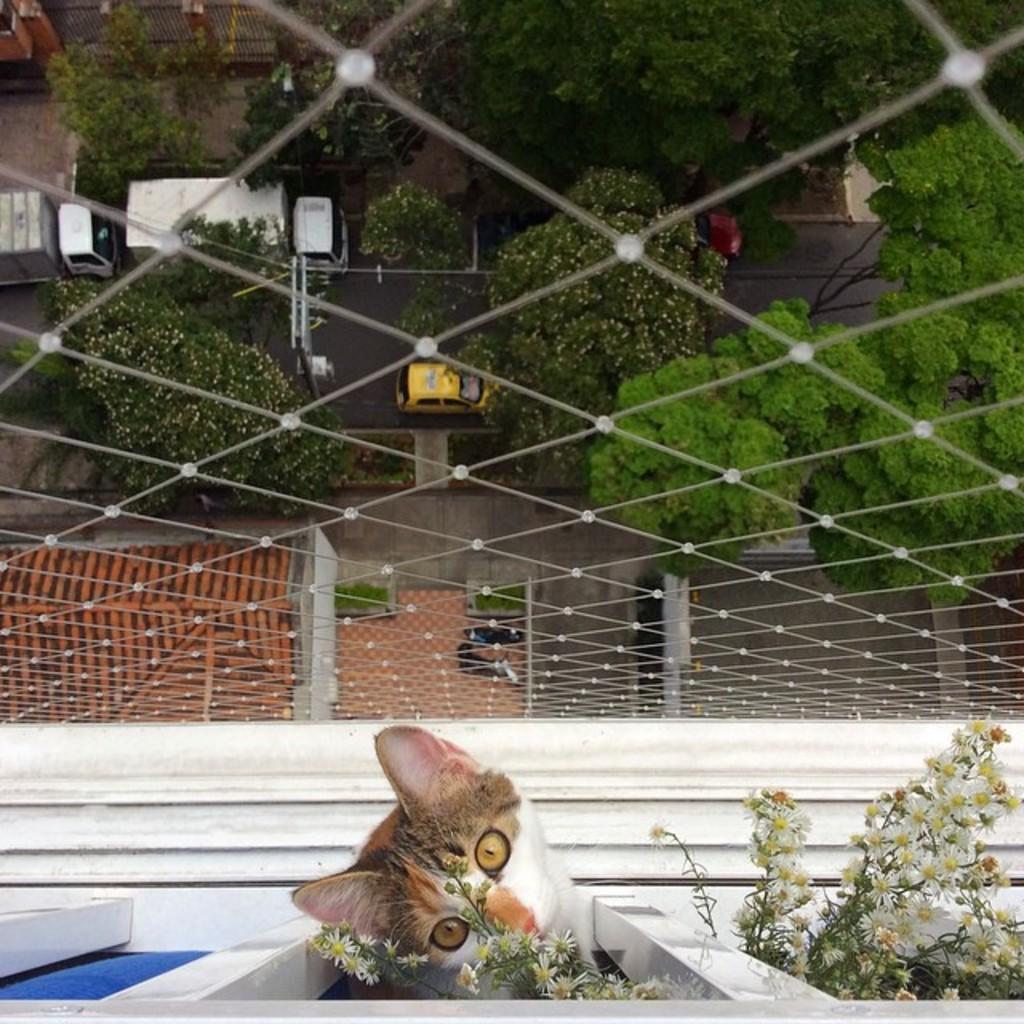Describe this image in one or two sentences. In the image we can see there is a cat looking at flowers and the flowers are on plants. There is an iron fencing and behind there are trees. There are vehicles parked on the road and there is a building. 